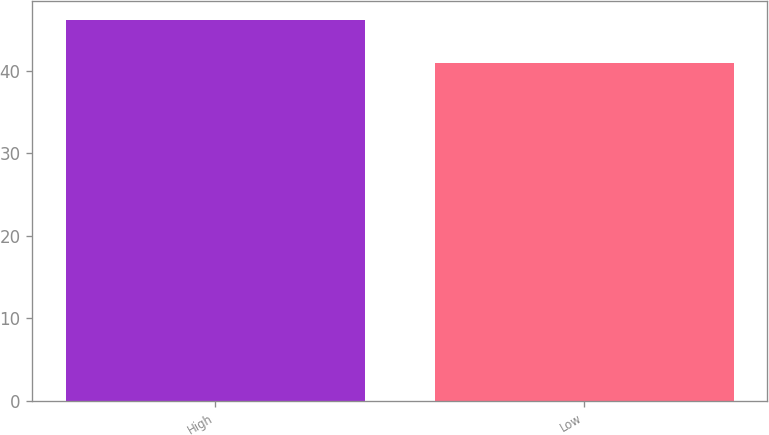Convert chart to OTSL. <chart><loc_0><loc_0><loc_500><loc_500><bar_chart><fcel>High<fcel>Low<nl><fcel>46.21<fcel>40.94<nl></chart> 